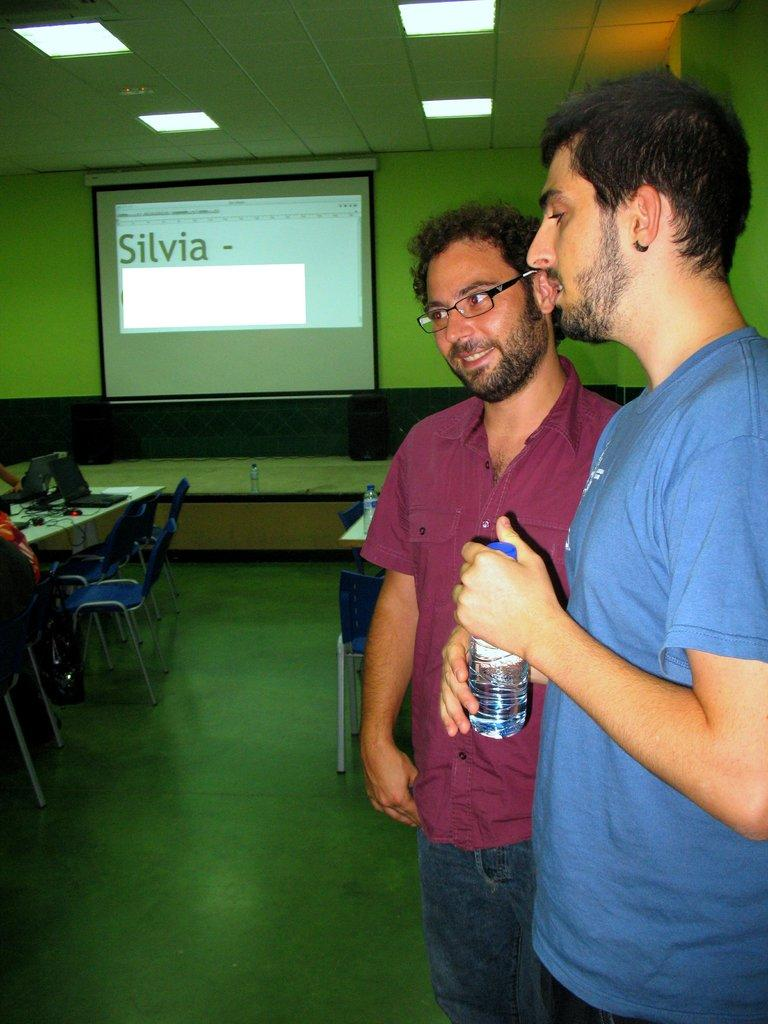How many people are in the image? There are two men standing in the image. What are the men holding in their hands? The men are holding water bottles in their hands. What can be seen behind the men in the image? There is a projector screen in the image. What is the primary piece of furniture in the image? There is a table in the image. What else can be found on the table besides the projector screen? Other objects are present on the table. What is the men's opinion on the topic of hate in the image? There is no indication in the image of the men's opinions on any topic, including hate. 